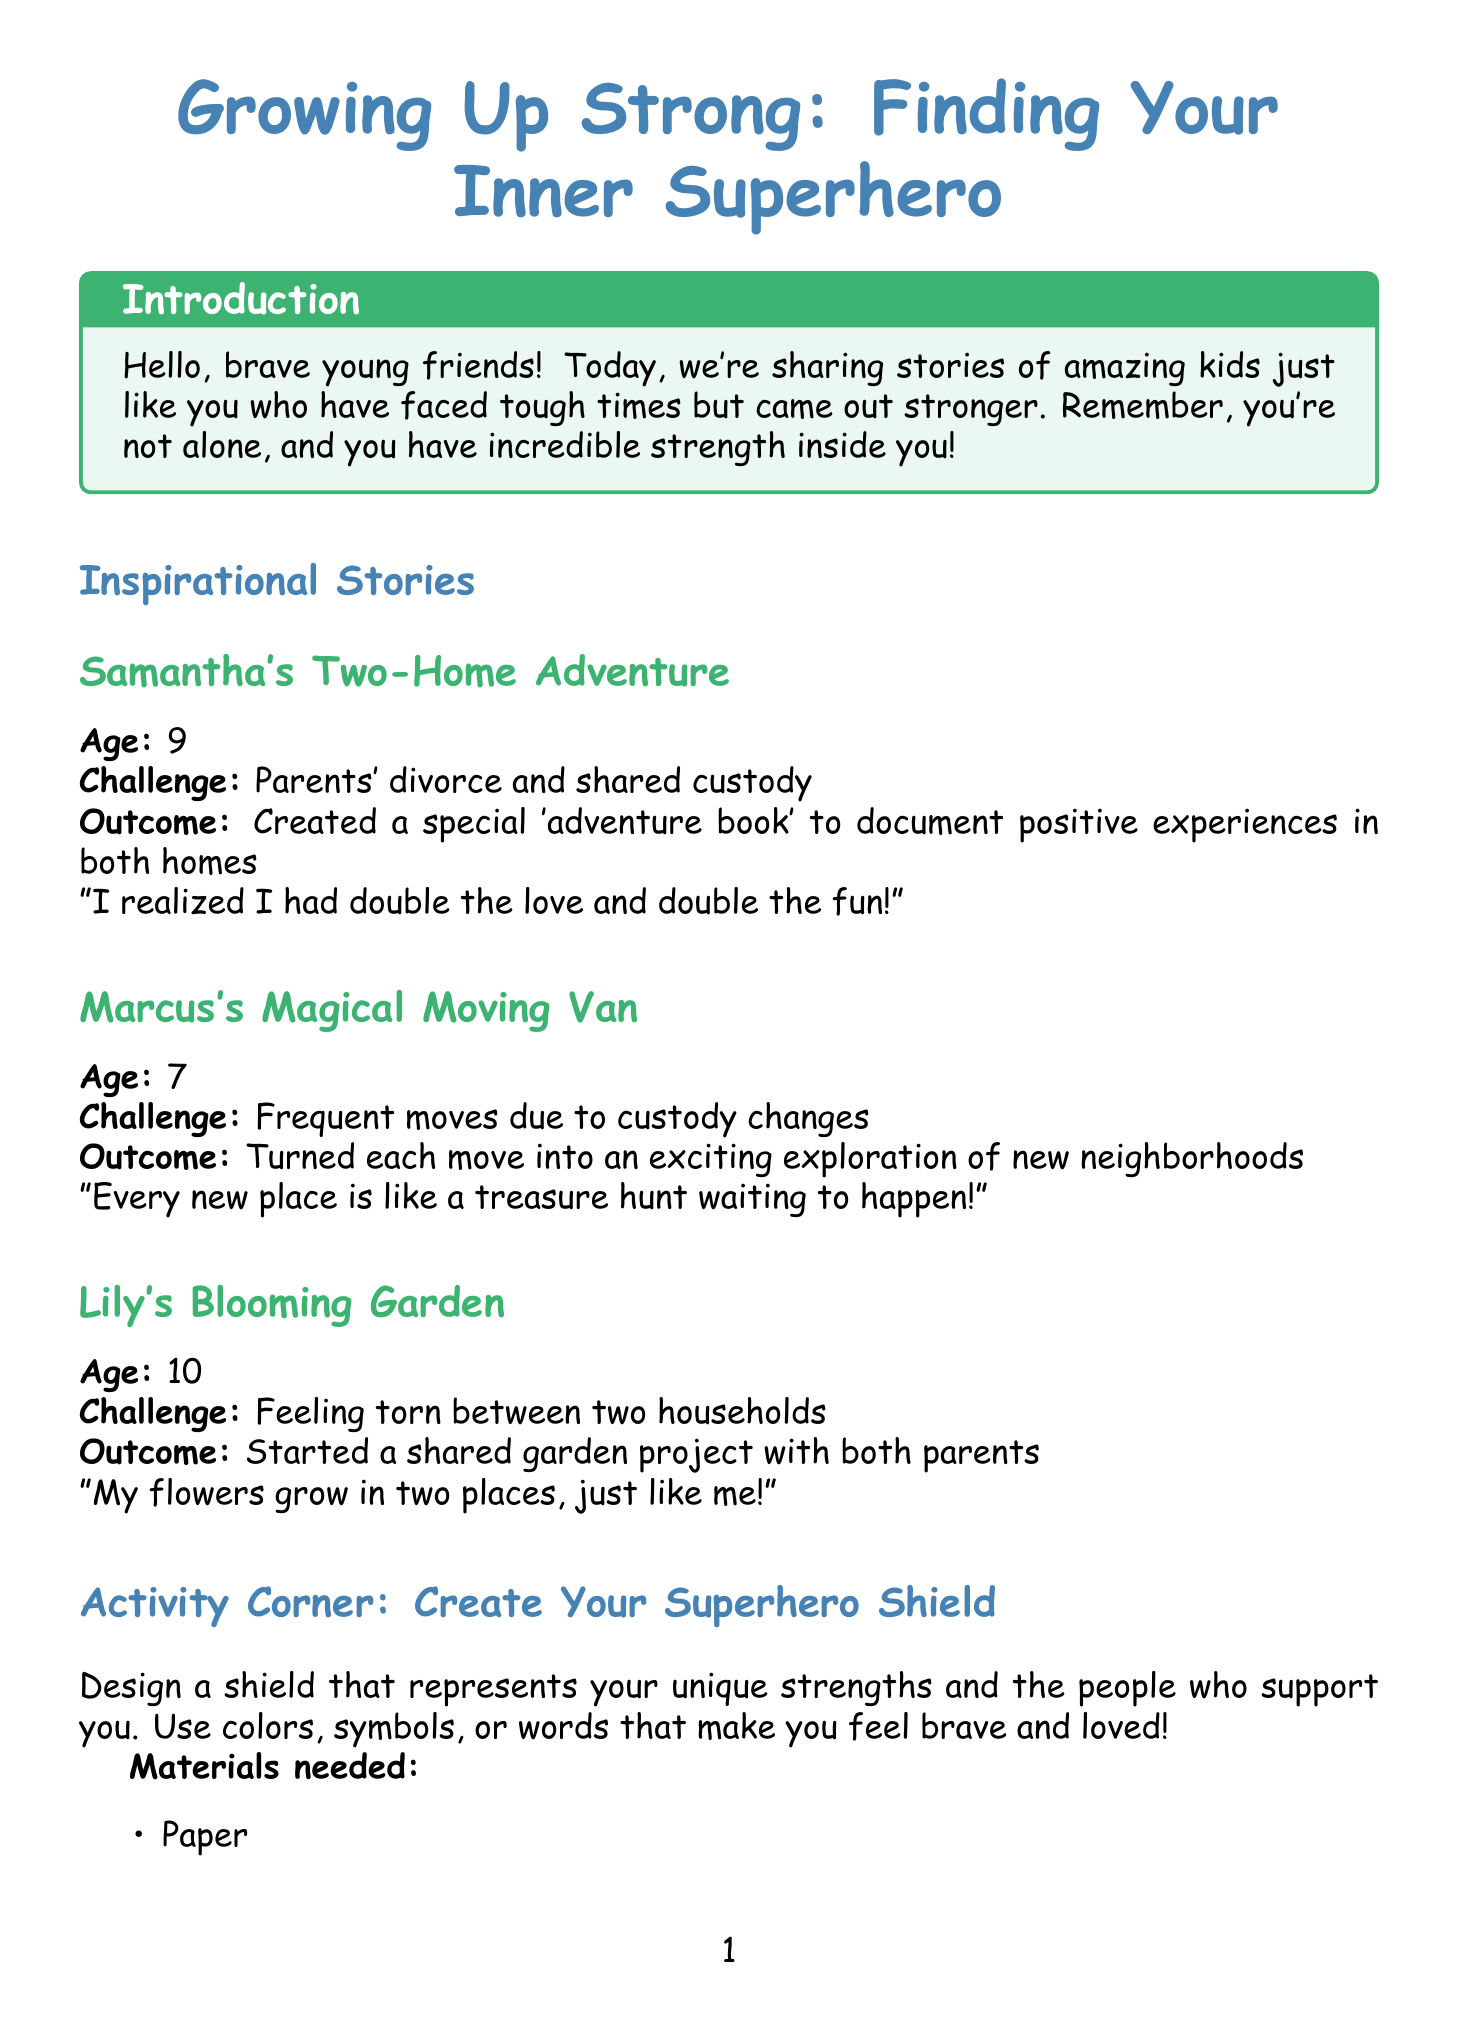What is the title of the newsletter? The title of the newsletter is prominently stated at the beginning of the document.
Answer: Growing Up Strong: Finding Your Inner Superhero How old is Samantha? Samantha's age is mentioned in her story section.
Answer: 9 What challenge did Marcus face? Marcus's challenge is clearly stated in his story, describing the difficulties he experienced.
Answer: Frequent moves due to custody changes What did Lily start with both parents? The specific project that Lily initiated is included in her story's outcome.
Answer: A shared garden project Who authored the book "The Invisible String"? The author of the book is listed in the resources section of the document.
Answer: Patrice Karst What activity is suggested in the Activity Corner? The Activity Corner describes a creative activity for young readers.
Answer: Create Your Superhero Shield What is Dr. Emily Chen's profession? Dr. Emily Chen's role is noted in the expert tip section.
Answer: Child Psychologist How many books are listed in the Helpful Books section? The number of books is evident from the list presented in the resource section.
Answer: 3 